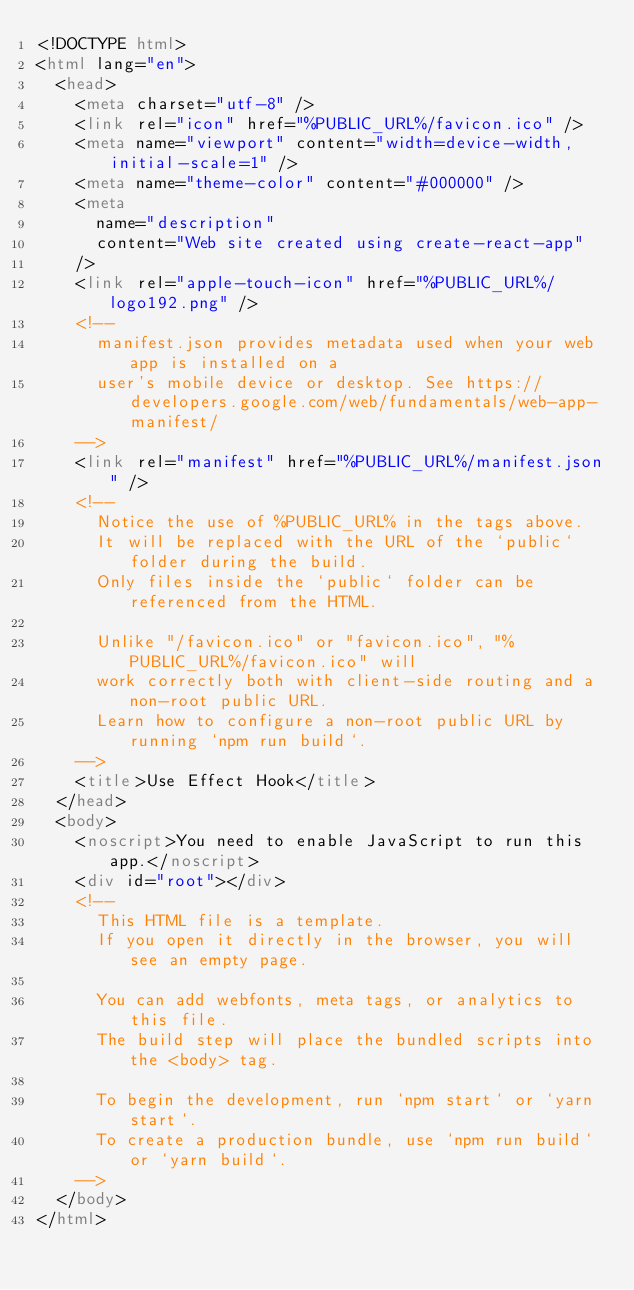<code> <loc_0><loc_0><loc_500><loc_500><_HTML_><!DOCTYPE html>
<html lang="en">
  <head>
    <meta charset="utf-8" />
    <link rel="icon" href="%PUBLIC_URL%/favicon.ico" />
    <meta name="viewport" content="width=device-width, initial-scale=1" />
    <meta name="theme-color" content="#000000" />
    <meta
      name="description"
      content="Web site created using create-react-app"
    />
    <link rel="apple-touch-icon" href="%PUBLIC_URL%/logo192.png" />
    <!--
      manifest.json provides metadata used when your web app is installed on a
      user's mobile device or desktop. See https://developers.google.com/web/fundamentals/web-app-manifest/
    -->
    <link rel="manifest" href="%PUBLIC_URL%/manifest.json" />
    <!--
      Notice the use of %PUBLIC_URL% in the tags above.
      It will be replaced with the URL of the `public` folder during the build.
      Only files inside the `public` folder can be referenced from the HTML.

      Unlike "/favicon.ico" or "favicon.ico", "%PUBLIC_URL%/favicon.ico" will
      work correctly both with client-side routing and a non-root public URL.
      Learn how to configure a non-root public URL by running `npm run build`.
    -->
    <title>Use Effect Hook</title>
  </head>
  <body>
    <noscript>You need to enable JavaScript to run this app.</noscript>
    <div id="root"></div>
    <!--
      This HTML file is a template.
      If you open it directly in the browser, you will see an empty page.

      You can add webfonts, meta tags, or analytics to this file.
      The build step will place the bundled scripts into the <body> tag.

      To begin the development, run `npm start` or `yarn start`.
      To create a production bundle, use `npm run build` or `yarn build`.
    -->
  </body>
</html>
</code> 